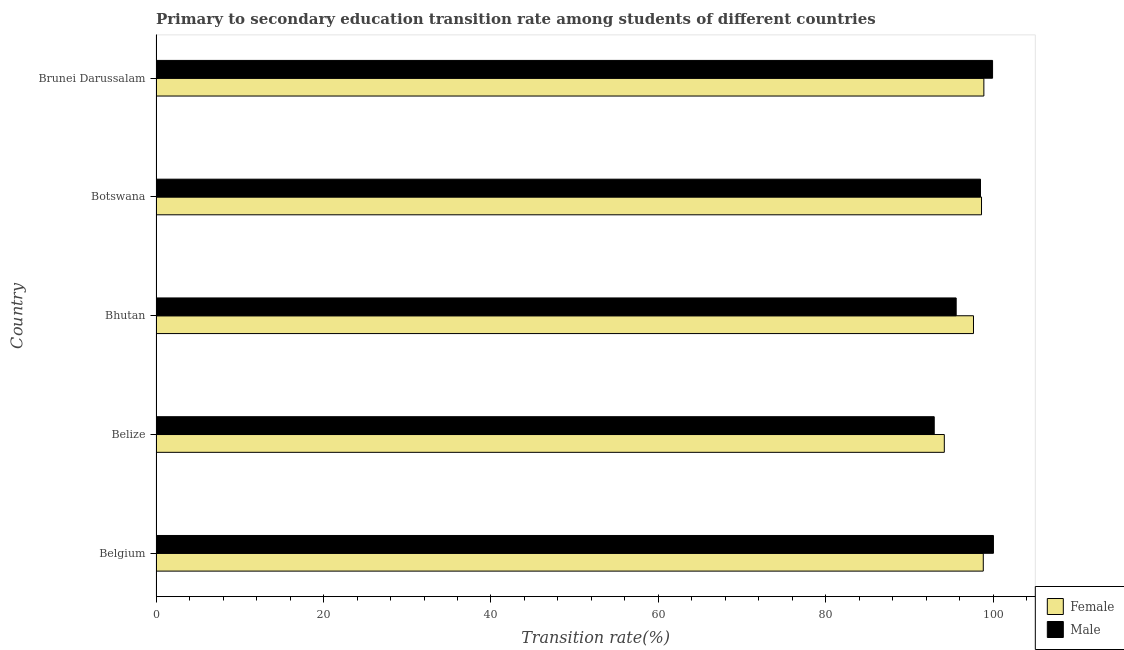Are the number of bars per tick equal to the number of legend labels?
Make the answer very short. Yes. How many bars are there on the 4th tick from the top?
Your response must be concise. 2. What is the label of the 2nd group of bars from the top?
Your response must be concise. Botswana. What is the transition rate among female students in Brunei Darussalam?
Your response must be concise. 98.86. Across all countries, what is the minimum transition rate among female students?
Provide a succinct answer. 94.13. In which country was the transition rate among male students minimum?
Ensure brevity in your answer.  Belize. What is the total transition rate among female students in the graph?
Provide a short and direct response. 487.97. What is the difference between the transition rate among male students in Botswana and that in Brunei Darussalam?
Provide a short and direct response. -1.44. What is the difference between the transition rate among female students in Botswana and the transition rate among male students in Belize?
Make the answer very short. 5.65. What is the average transition rate among male students per country?
Ensure brevity in your answer.  97.37. What is the difference between the transition rate among female students and transition rate among male students in Botswana?
Your answer should be compact. 0.12. In how many countries, is the transition rate among male students greater than 60 %?
Give a very brief answer. 5. Is the difference between the transition rate among female students in Belgium and Bhutan greater than the difference between the transition rate among male students in Belgium and Bhutan?
Ensure brevity in your answer.  No. What is the difference between the highest and the second highest transition rate among male students?
Your answer should be very brief. 0.1. What is the difference between the highest and the lowest transition rate among male students?
Keep it short and to the point. 7.07. In how many countries, is the transition rate among female students greater than the average transition rate among female students taken over all countries?
Your response must be concise. 4. Is the sum of the transition rate among male students in Belize and Bhutan greater than the maximum transition rate among female students across all countries?
Offer a terse response. Yes. What does the 2nd bar from the top in Brunei Darussalam represents?
Make the answer very short. Female. What does the 1st bar from the bottom in Belize represents?
Your answer should be very brief. Female. How many bars are there?
Your answer should be compact. 10. How many countries are there in the graph?
Offer a terse response. 5. What is the difference between two consecutive major ticks on the X-axis?
Ensure brevity in your answer.  20. Does the graph contain grids?
Your answer should be very brief. No. Where does the legend appear in the graph?
Ensure brevity in your answer.  Bottom right. How many legend labels are there?
Your response must be concise. 2. What is the title of the graph?
Make the answer very short. Primary to secondary education transition rate among students of different countries. What is the label or title of the X-axis?
Give a very brief answer. Transition rate(%). What is the Transition rate(%) in Female in Belgium?
Provide a short and direct response. 98.79. What is the Transition rate(%) in Male in Belgium?
Your response must be concise. 100. What is the Transition rate(%) in Female in Belize?
Offer a very short reply. 94.13. What is the Transition rate(%) of Male in Belize?
Your response must be concise. 92.93. What is the Transition rate(%) in Female in Bhutan?
Provide a short and direct response. 97.62. What is the Transition rate(%) of Male in Bhutan?
Offer a terse response. 95.55. What is the Transition rate(%) of Female in Botswana?
Provide a succinct answer. 98.58. What is the Transition rate(%) in Male in Botswana?
Your response must be concise. 98.46. What is the Transition rate(%) in Female in Brunei Darussalam?
Your response must be concise. 98.86. What is the Transition rate(%) of Male in Brunei Darussalam?
Keep it short and to the point. 99.9. Across all countries, what is the maximum Transition rate(%) of Female?
Ensure brevity in your answer.  98.86. Across all countries, what is the minimum Transition rate(%) of Female?
Your answer should be compact. 94.13. Across all countries, what is the minimum Transition rate(%) of Male?
Provide a short and direct response. 92.93. What is the total Transition rate(%) of Female in the graph?
Your answer should be compact. 487.97. What is the total Transition rate(%) of Male in the graph?
Offer a very short reply. 486.83. What is the difference between the Transition rate(%) in Female in Belgium and that in Belize?
Your answer should be very brief. 4.65. What is the difference between the Transition rate(%) of Male in Belgium and that in Belize?
Make the answer very short. 7.07. What is the difference between the Transition rate(%) of Female in Belgium and that in Bhutan?
Ensure brevity in your answer.  1.17. What is the difference between the Transition rate(%) of Male in Belgium and that in Bhutan?
Offer a terse response. 4.45. What is the difference between the Transition rate(%) of Female in Belgium and that in Botswana?
Offer a very short reply. 0.21. What is the difference between the Transition rate(%) of Male in Belgium and that in Botswana?
Your answer should be compact. 1.54. What is the difference between the Transition rate(%) in Female in Belgium and that in Brunei Darussalam?
Your response must be concise. -0.07. What is the difference between the Transition rate(%) of Male in Belgium and that in Brunei Darussalam?
Provide a succinct answer. 0.1. What is the difference between the Transition rate(%) of Female in Belize and that in Bhutan?
Ensure brevity in your answer.  -3.48. What is the difference between the Transition rate(%) of Male in Belize and that in Bhutan?
Provide a short and direct response. -2.62. What is the difference between the Transition rate(%) in Female in Belize and that in Botswana?
Keep it short and to the point. -4.44. What is the difference between the Transition rate(%) in Male in Belize and that in Botswana?
Offer a terse response. -5.52. What is the difference between the Transition rate(%) of Female in Belize and that in Brunei Darussalam?
Your answer should be compact. -4.72. What is the difference between the Transition rate(%) in Male in Belize and that in Brunei Darussalam?
Give a very brief answer. -6.97. What is the difference between the Transition rate(%) of Female in Bhutan and that in Botswana?
Your answer should be very brief. -0.96. What is the difference between the Transition rate(%) in Male in Bhutan and that in Botswana?
Offer a very short reply. -2.9. What is the difference between the Transition rate(%) of Female in Bhutan and that in Brunei Darussalam?
Keep it short and to the point. -1.24. What is the difference between the Transition rate(%) in Male in Bhutan and that in Brunei Darussalam?
Give a very brief answer. -4.35. What is the difference between the Transition rate(%) of Female in Botswana and that in Brunei Darussalam?
Your answer should be compact. -0.28. What is the difference between the Transition rate(%) of Male in Botswana and that in Brunei Darussalam?
Make the answer very short. -1.44. What is the difference between the Transition rate(%) of Female in Belgium and the Transition rate(%) of Male in Belize?
Give a very brief answer. 5.86. What is the difference between the Transition rate(%) of Female in Belgium and the Transition rate(%) of Male in Bhutan?
Offer a terse response. 3.24. What is the difference between the Transition rate(%) in Female in Belgium and the Transition rate(%) in Male in Botswana?
Give a very brief answer. 0.33. What is the difference between the Transition rate(%) in Female in Belgium and the Transition rate(%) in Male in Brunei Darussalam?
Your response must be concise. -1.11. What is the difference between the Transition rate(%) of Female in Belize and the Transition rate(%) of Male in Bhutan?
Your response must be concise. -1.42. What is the difference between the Transition rate(%) of Female in Belize and the Transition rate(%) of Male in Botswana?
Provide a short and direct response. -4.32. What is the difference between the Transition rate(%) in Female in Belize and the Transition rate(%) in Male in Brunei Darussalam?
Offer a terse response. -5.76. What is the difference between the Transition rate(%) of Female in Bhutan and the Transition rate(%) of Male in Botswana?
Give a very brief answer. -0.84. What is the difference between the Transition rate(%) in Female in Bhutan and the Transition rate(%) in Male in Brunei Darussalam?
Keep it short and to the point. -2.28. What is the difference between the Transition rate(%) in Female in Botswana and the Transition rate(%) in Male in Brunei Darussalam?
Make the answer very short. -1.32. What is the average Transition rate(%) of Female per country?
Your answer should be very brief. 97.59. What is the average Transition rate(%) in Male per country?
Offer a very short reply. 97.37. What is the difference between the Transition rate(%) in Female and Transition rate(%) in Male in Belgium?
Keep it short and to the point. -1.21. What is the difference between the Transition rate(%) in Female and Transition rate(%) in Male in Belize?
Your response must be concise. 1.2. What is the difference between the Transition rate(%) of Female and Transition rate(%) of Male in Bhutan?
Your answer should be compact. 2.07. What is the difference between the Transition rate(%) in Female and Transition rate(%) in Male in Botswana?
Offer a terse response. 0.12. What is the difference between the Transition rate(%) in Female and Transition rate(%) in Male in Brunei Darussalam?
Your response must be concise. -1.04. What is the ratio of the Transition rate(%) of Female in Belgium to that in Belize?
Provide a short and direct response. 1.05. What is the ratio of the Transition rate(%) in Male in Belgium to that in Belize?
Offer a very short reply. 1.08. What is the ratio of the Transition rate(%) in Female in Belgium to that in Bhutan?
Provide a short and direct response. 1.01. What is the ratio of the Transition rate(%) in Male in Belgium to that in Bhutan?
Make the answer very short. 1.05. What is the ratio of the Transition rate(%) in Female in Belgium to that in Botswana?
Give a very brief answer. 1. What is the ratio of the Transition rate(%) of Male in Belgium to that in Botswana?
Make the answer very short. 1.02. What is the ratio of the Transition rate(%) of Female in Belize to that in Bhutan?
Your answer should be very brief. 0.96. What is the ratio of the Transition rate(%) in Male in Belize to that in Bhutan?
Ensure brevity in your answer.  0.97. What is the ratio of the Transition rate(%) of Female in Belize to that in Botswana?
Provide a succinct answer. 0.95. What is the ratio of the Transition rate(%) in Male in Belize to that in Botswana?
Your answer should be compact. 0.94. What is the ratio of the Transition rate(%) of Female in Belize to that in Brunei Darussalam?
Your answer should be very brief. 0.95. What is the ratio of the Transition rate(%) of Male in Belize to that in Brunei Darussalam?
Provide a short and direct response. 0.93. What is the ratio of the Transition rate(%) in Female in Bhutan to that in Botswana?
Your answer should be compact. 0.99. What is the ratio of the Transition rate(%) in Male in Bhutan to that in Botswana?
Your answer should be very brief. 0.97. What is the ratio of the Transition rate(%) of Female in Bhutan to that in Brunei Darussalam?
Make the answer very short. 0.99. What is the ratio of the Transition rate(%) of Male in Bhutan to that in Brunei Darussalam?
Your response must be concise. 0.96. What is the ratio of the Transition rate(%) of Male in Botswana to that in Brunei Darussalam?
Your answer should be compact. 0.99. What is the difference between the highest and the second highest Transition rate(%) in Female?
Offer a very short reply. 0.07. What is the difference between the highest and the second highest Transition rate(%) in Male?
Your answer should be very brief. 0.1. What is the difference between the highest and the lowest Transition rate(%) in Female?
Offer a terse response. 4.72. What is the difference between the highest and the lowest Transition rate(%) of Male?
Keep it short and to the point. 7.07. 